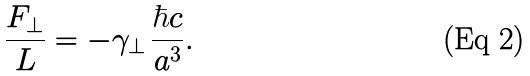Convert formula to latex. <formula><loc_0><loc_0><loc_500><loc_500>\frac { F _ { \bot } } { L } = - \gamma _ { \bot } \, \frac { \hbar { c } } { a ^ { 3 } } .</formula> 